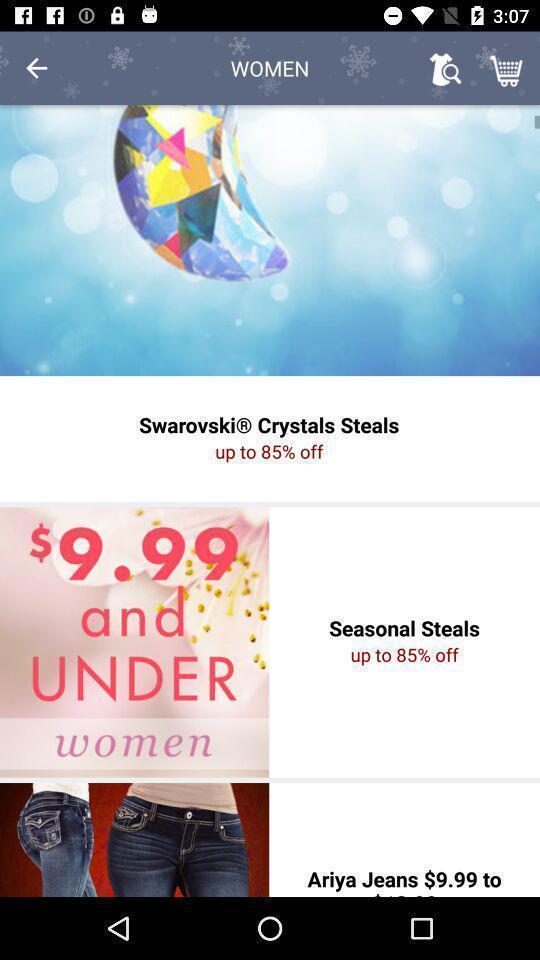Provide a detailed account of this screenshot. Page shows the discount offers on shopping app. 